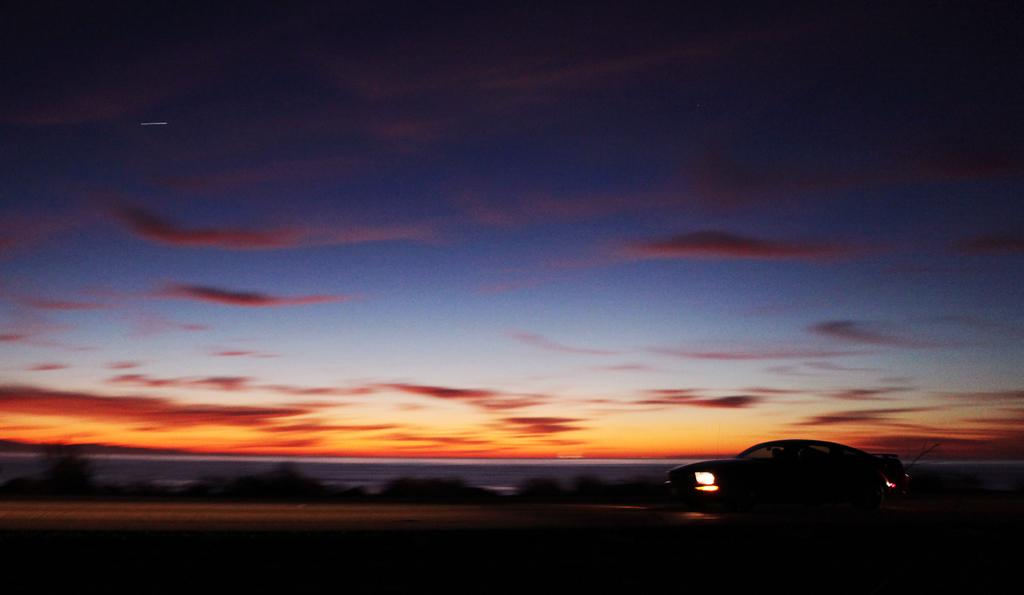What is the main subject of the image? The main subject of the image is a car on the road. What can be seen in the background of the image? The sky is visible in the background of the image. What type of force is being applied to the pot in the image? There is no pot present in the image, and therefore no force is being applied to it. How is the pot being used to measure the ingredients in the image? There is no pot or ingredients present in the image, so it cannot be used for measuring. 